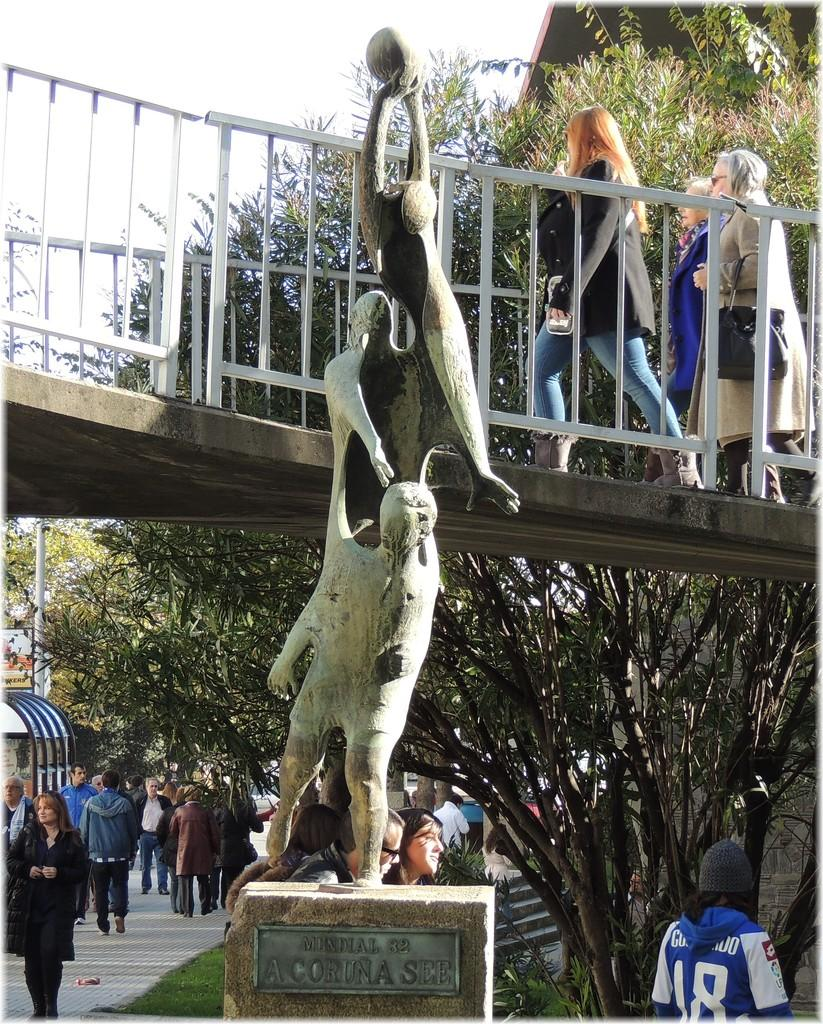<image>
Write a terse but informative summary of the picture. a statue with the word Coruna on it 